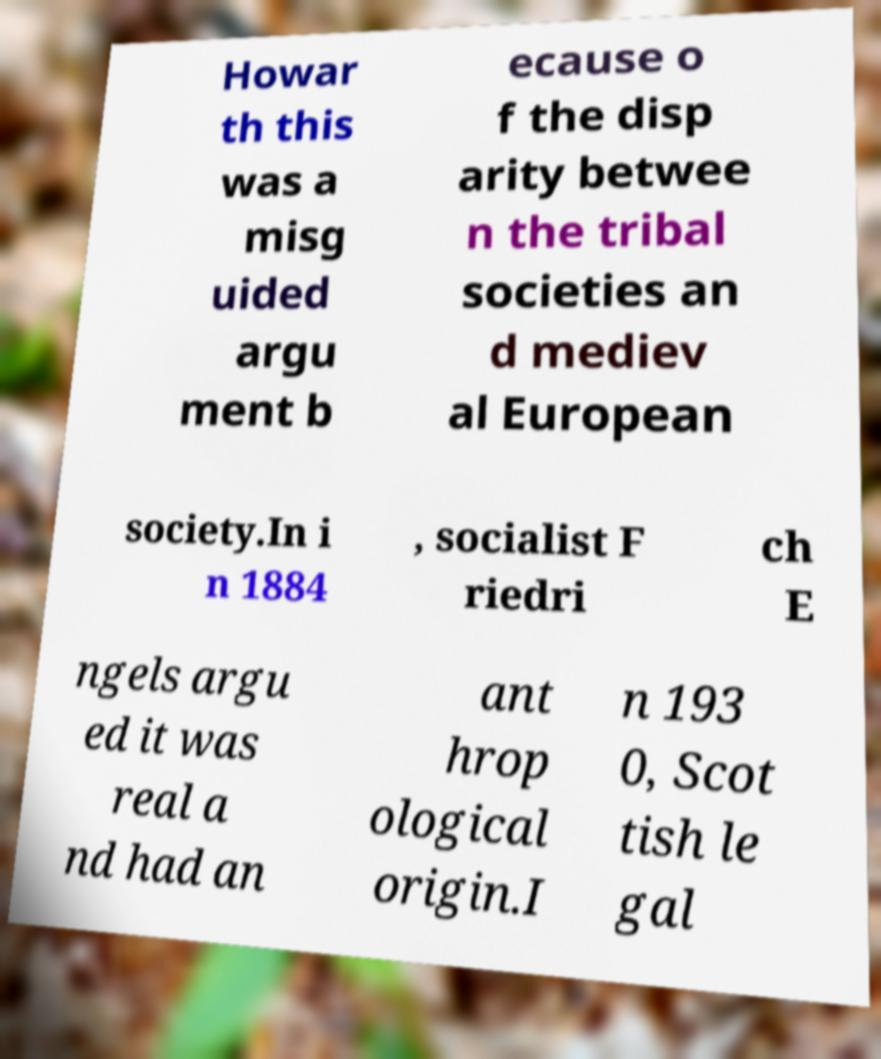Could you extract and type out the text from this image? Howar th this was a misg uided argu ment b ecause o f the disp arity betwee n the tribal societies an d mediev al European society.In i n 1884 , socialist F riedri ch E ngels argu ed it was real a nd had an ant hrop ological origin.I n 193 0, Scot tish le gal 